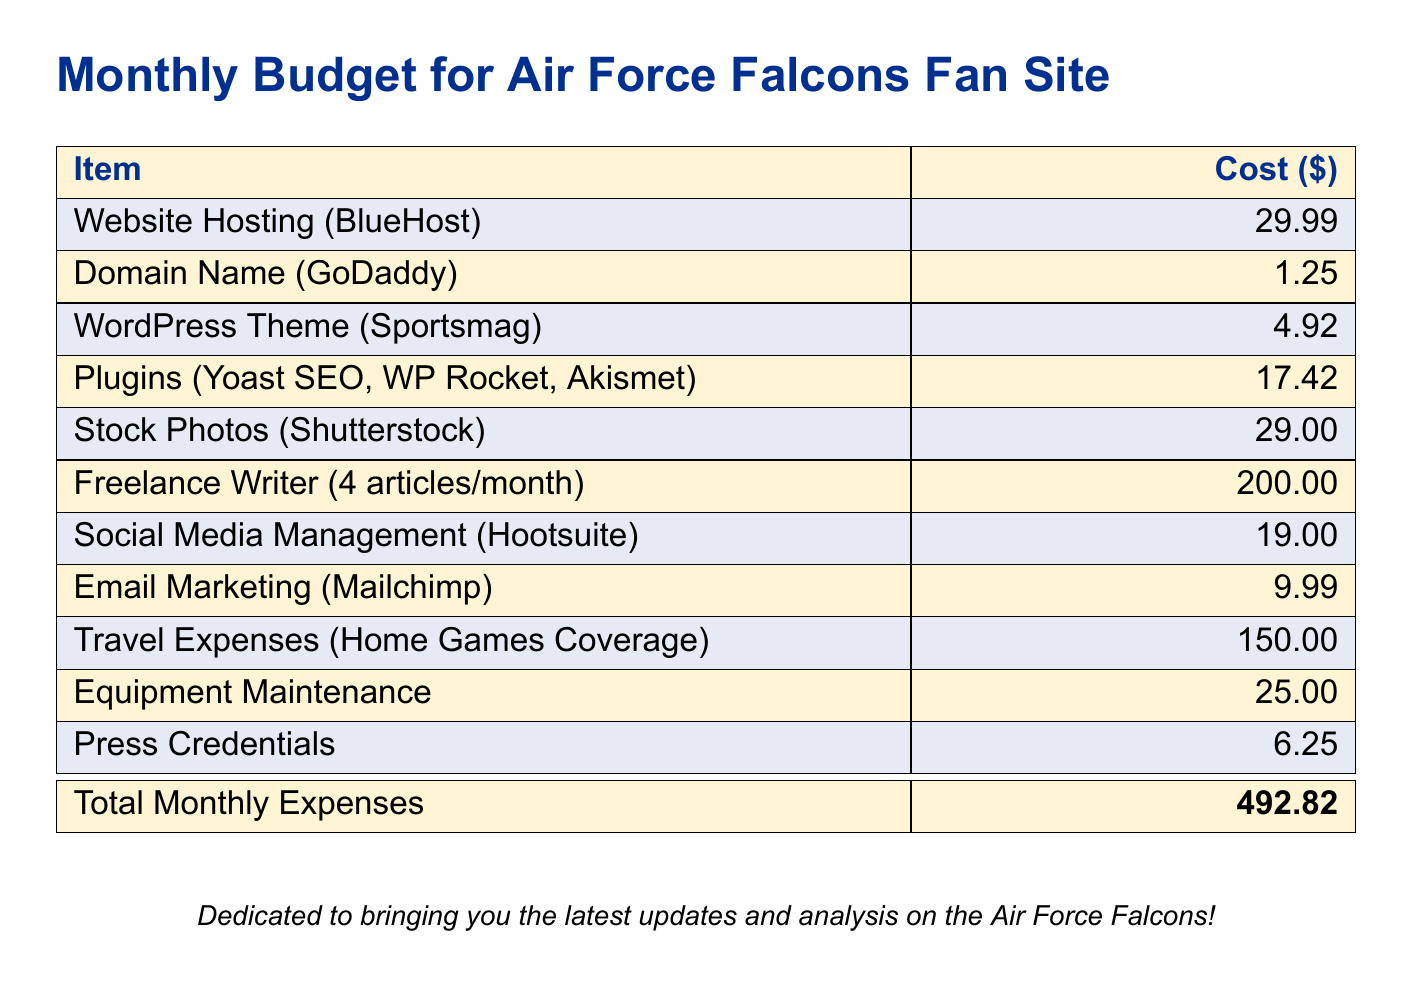What is the total monthly expenses? The total monthly expenses is clearly stated in the document as the sum of all listed costs.
Answer: 492.82 How much does website hosting cost? The document specifies the cost of website hosting under the relevant item.
Answer: 29.99 What is the cost of freelance writing per month? The document provides the cost associated with freelance writing listed as a separate item.
Answer: 200.00 What is the monthly cost for stock photos? The price for stock photos is mentioned specifically in the budget.
Answer: 29.00 How much is paid for social media management? The budget clearly indicates the monthly cost for social media management services.
Answer: 19.00 What is the cost for domain name registration? The document mentions the expense for the domain name explicitly.
Answer: 1.25 What is the cost for travel expenses associated with home games coverage? The travel expenses item gives a specific amount allocated for this purpose.
Answer: 150.00 What is the price of the WordPress theme? The document lists the cost for the WordPress theme under its name.
Answer: 4.92 How many articles are produced by the freelance writer each month? The document specifies the number of articles written by the freelance writer monthly.
Answer: 4 What is the expense for equipment maintenance? The document states the cost allocated for maintaining equipment used for journalism.
Answer: 25.00 